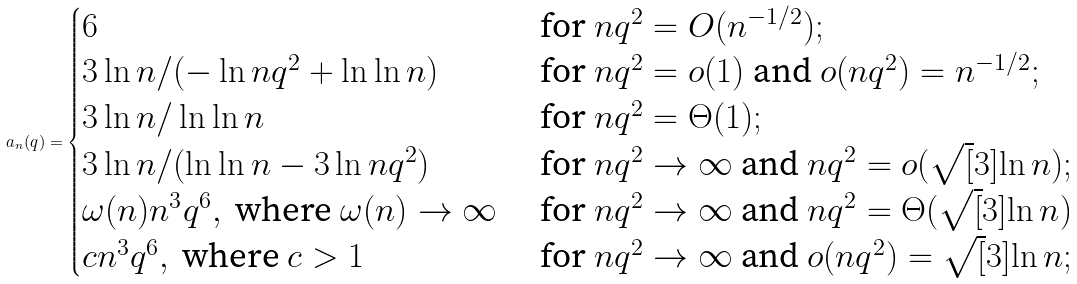Convert formula to latex. <formula><loc_0><loc_0><loc_500><loc_500>a _ { n } ( q ) = \begin{cases} 6 & \text { for } n q ^ { 2 } = O ( n ^ { - 1 / 2 } ) ; \\ 3 \ln n / ( - \ln n q ^ { 2 } + \ln \ln n ) & \text { for } n q ^ { 2 } = o ( 1 ) \text { and } o ( n q ^ { 2 } ) = n ^ { - 1 / 2 } ; \\ 3 \ln n / \ln \ln n & \text { for } n q ^ { 2 } = \Theta ( 1 ) ; \\ 3 \ln n / ( \ln \ln n - 3 \ln n q ^ { 2 } ) & \text { for } n q ^ { 2 } \to \infty \text { and } n q ^ { 2 } = o ( \sqrt { [ } 3 ] { \ln n } ) ; \\ \omega ( n ) n ^ { 3 } q ^ { 6 } , \text { where } \omega ( n ) \to \infty & \text { for } n q ^ { 2 } \to \infty \text { and } n q ^ { 2 } = \Theta ( \sqrt { [ } 3 ] { \ln n } ) \\ c n ^ { 3 } q ^ { 6 } , \text { where } c > 1 & \text { for } n q ^ { 2 } \to \infty \text { and } o ( n q ^ { 2 } ) = \sqrt { [ } 3 ] { \ln n } ; \\ \end{cases}</formula> 